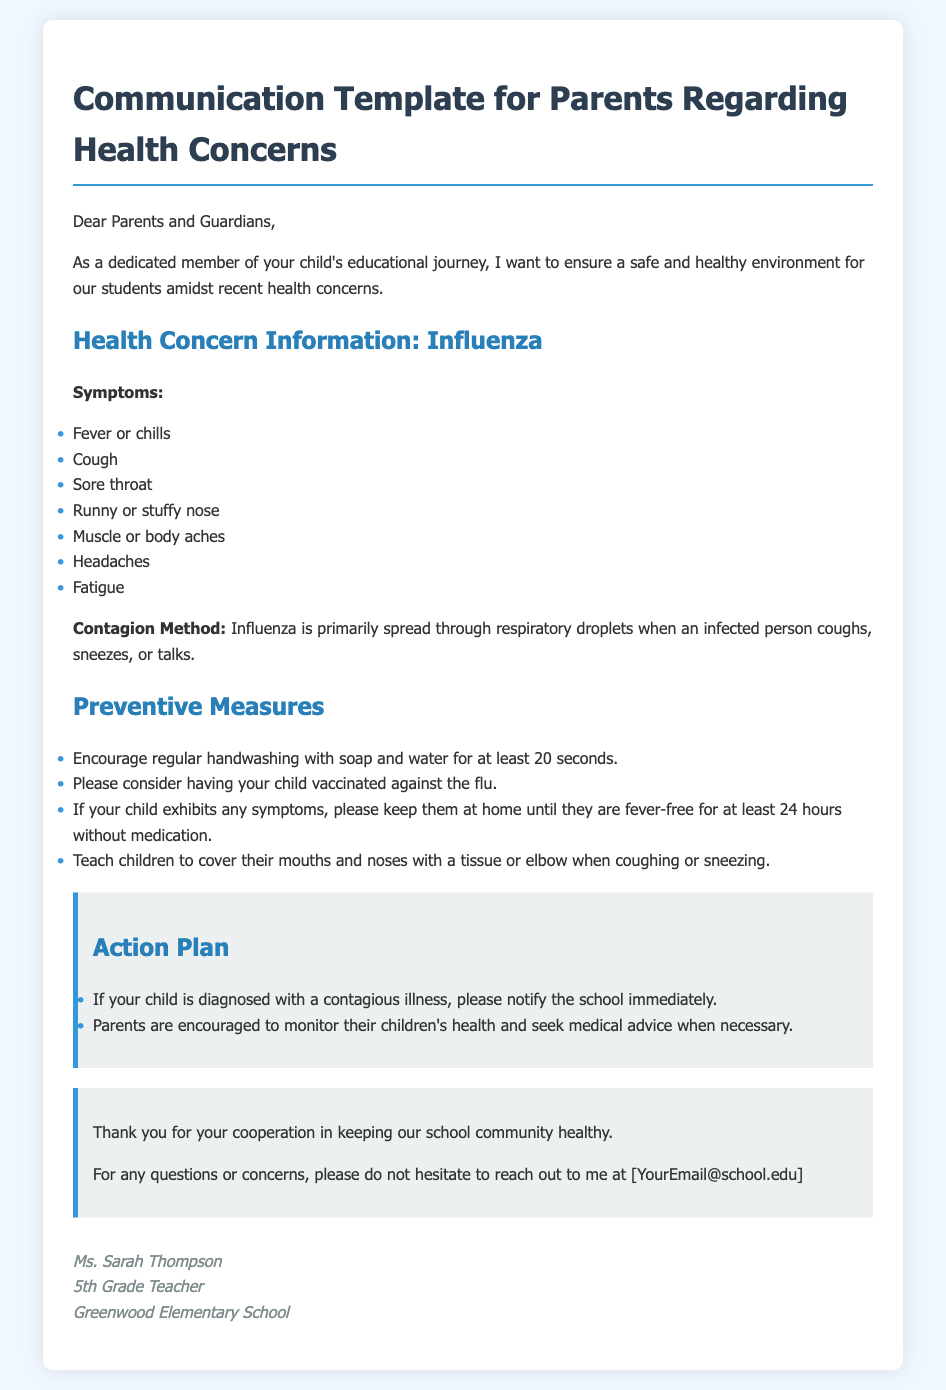What are the symptoms of influenza? The symptoms listed in the document include fever or chills, cough, sore throat, runny or stuffy nose, muscle or body aches, headaches, and fatigue.
Answer: Fever or chills, cough, sore throat, runny or stuffy nose, muscle or body aches, headaches, fatigue How should children cover their mouths when coughing or sneezing? The document advises teaching children to cover their mouths and noses with a tissue or elbow when coughing or sneezing.
Answer: Tissue or elbow What action should parents take if their child is diagnosed with a contagious illness? Parents are instructed in the document to notify the school immediately if their child is diagnosed with a contagious illness.
Answer: Notify the school immediately How long should a child be fever-free before returning to school? According to the document, a child should be fever-free for at least 24 hours without medication before returning to school.
Answer: 24 hours What is the main method of spread for influenza? The document states that influenza is primarily spread through respiratory droplets when an infected person coughs, sneezes, or talks.
Answer: Respiratory droplets What is the title of the document? The title as stated in the document is "Communication Template for Parents Regarding Health Concerns."
Answer: Communication Template for Parents Regarding Health Concerns What is encouraged for children to prevent influenza? The document encourages parents to consider having their child vaccinated against the flu as a preventive measure.
Answer: Vaccination against the flu What should a parent do if they have questions or concerns? The document suggests that parents should not hesitate to reach out to Ms. Sarah Thompson for any questions or concerns.
Answer: Reach out to Ms. Sarah Thompson 